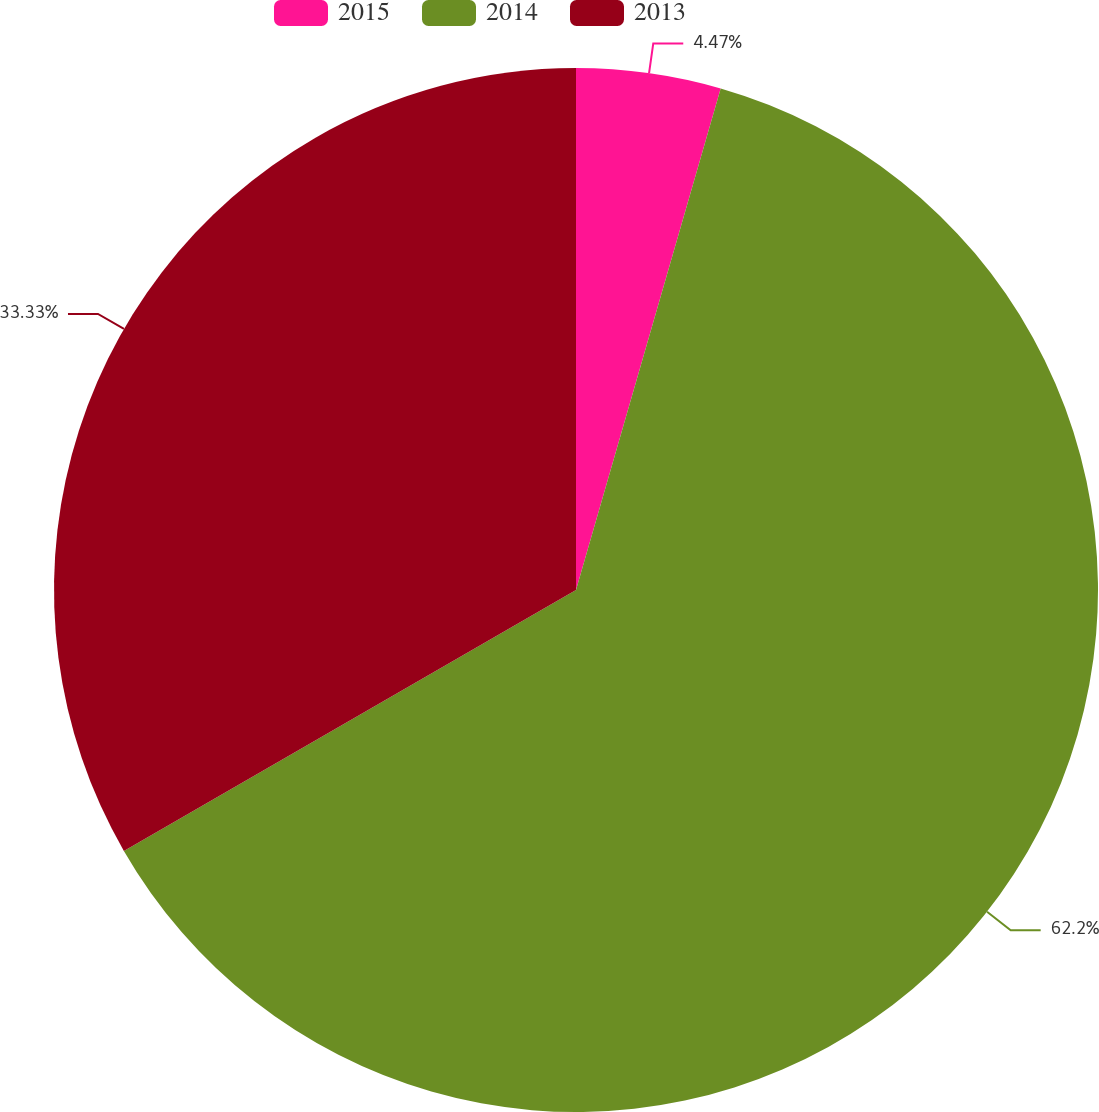Convert chart to OTSL. <chart><loc_0><loc_0><loc_500><loc_500><pie_chart><fcel>2015<fcel>2014<fcel>2013<nl><fcel>4.47%<fcel>62.2%<fcel>33.33%<nl></chart> 